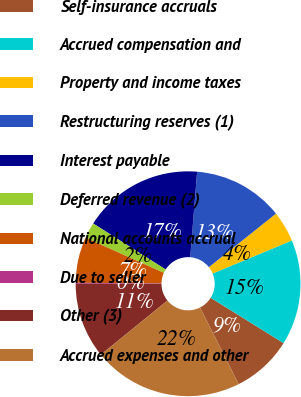Convert chart. <chart><loc_0><loc_0><loc_500><loc_500><pie_chart><fcel>Self-insurance accruals<fcel>Accrued compensation and<fcel>Property and income taxes<fcel>Restructuring reserves (1)<fcel>Interest payable<fcel>Deferred revenue (2)<fcel>National accounts accrual<fcel>Due to seller<fcel>Other (3)<fcel>Accrued expenses and other<nl><fcel>8.72%<fcel>15.14%<fcel>4.43%<fcel>13.0%<fcel>17.28%<fcel>2.29%<fcel>6.57%<fcel>0.15%<fcel>10.86%<fcel>21.56%<nl></chart> 